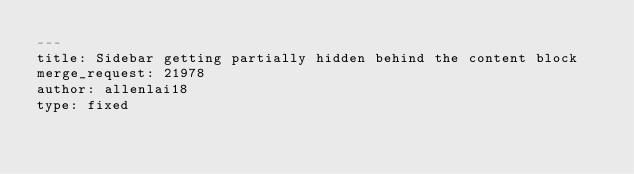Convert code to text. <code><loc_0><loc_0><loc_500><loc_500><_YAML_>---
title: Sidebar getting partially hidden behind the content block
merge_request: 21978
author: allenlai18
type: fixed
</code> 